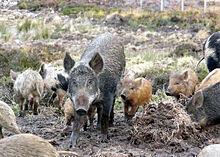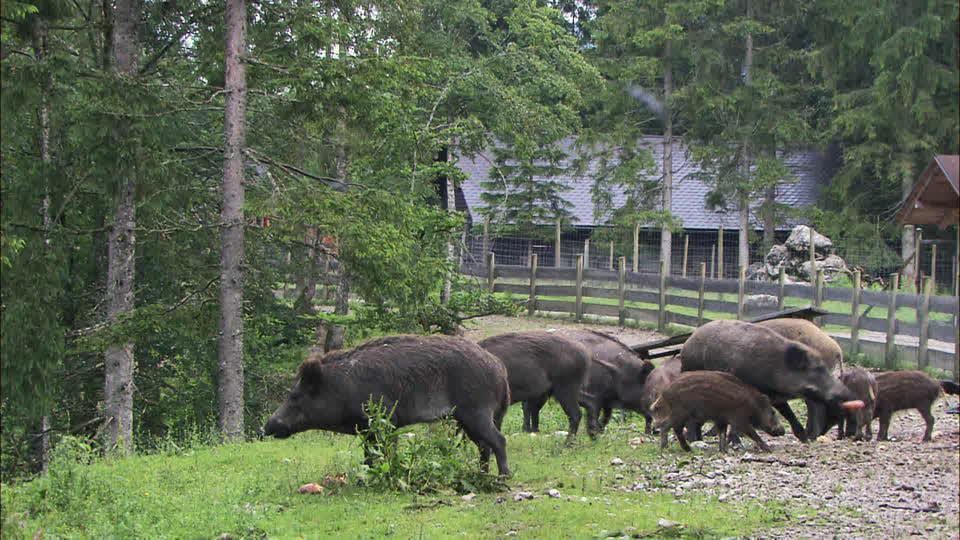The first image is the image on the left, the second image is the image on the right. Examine the images to the left and right. Is the description "At least one wild animal is wallowing in the mud." accurate? Answer yes or no. No. The first image is the image on the left, the second image is the image on the right. For the images shown, is this caption "An image shows at least one wild pig in the mud." true? Answer yes or no. No. 